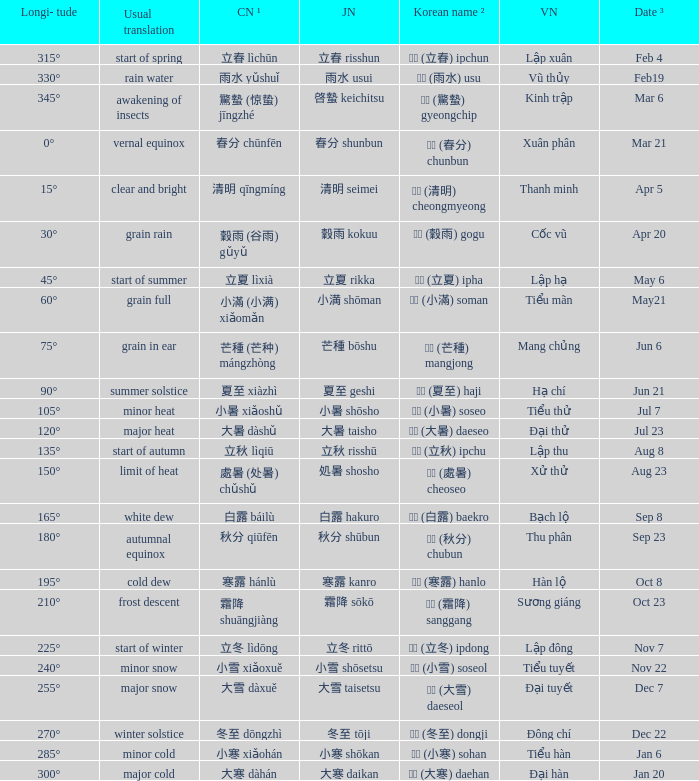Which Japanese name has a Korean name ² of 경칩 (驚蟄) gyeongchip? 啓蟄 keichitsu. 